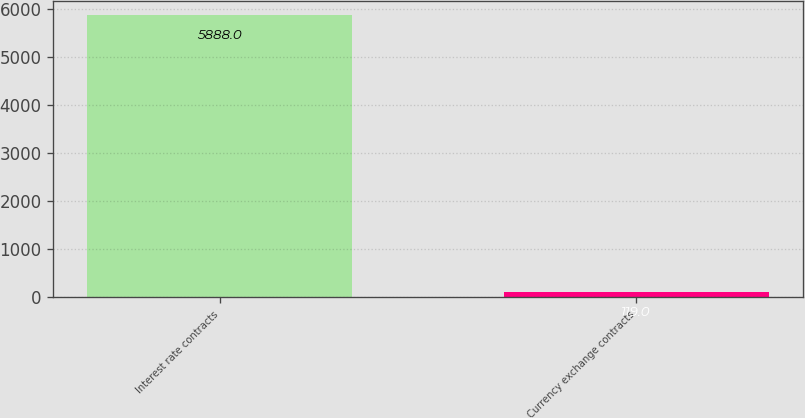<chart> <loc_0><loc_0><loc_500><loc_500><bar_chart><fcel>Interest rate contracts<fcel>Currency exchange contracts<nl><fcel>5888<fcel>119<nl></chart> 